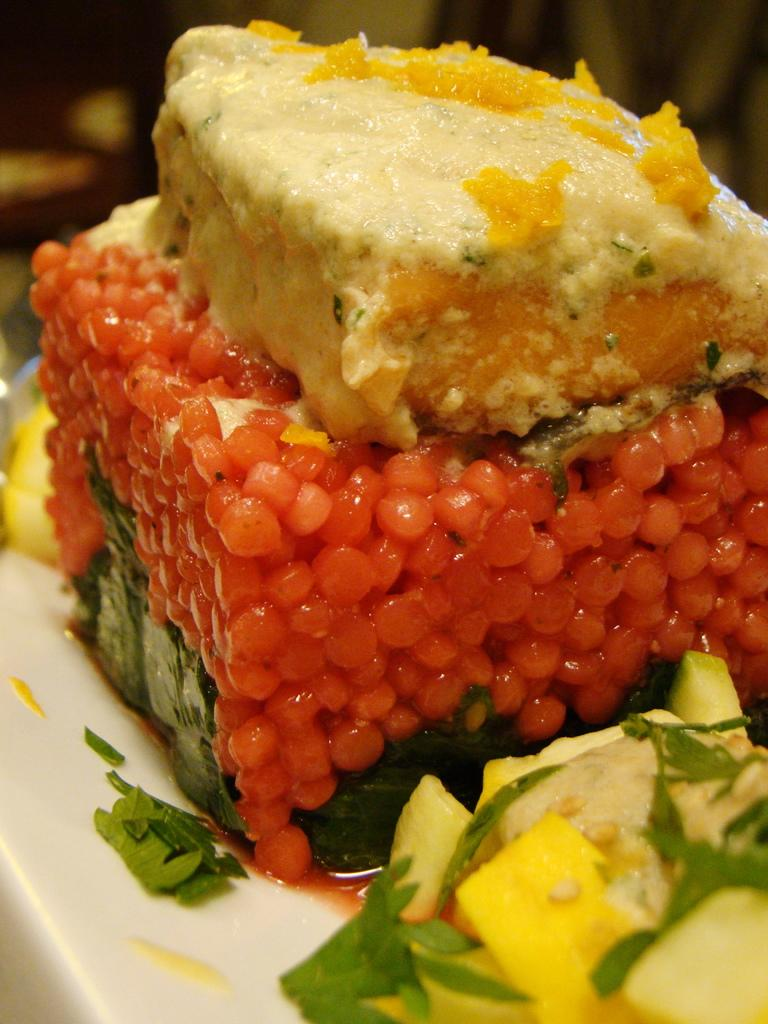What types of food can be seen in the image? There is different kind of food in the image. What is the food placed on? The food is on an object. Can you describe the background of the image? The background of the image is blurred. How many bees can be seen buzzing around the food in the image? There are no bees present in the image; it only shows different kinds of food on an object with a blurred background. 